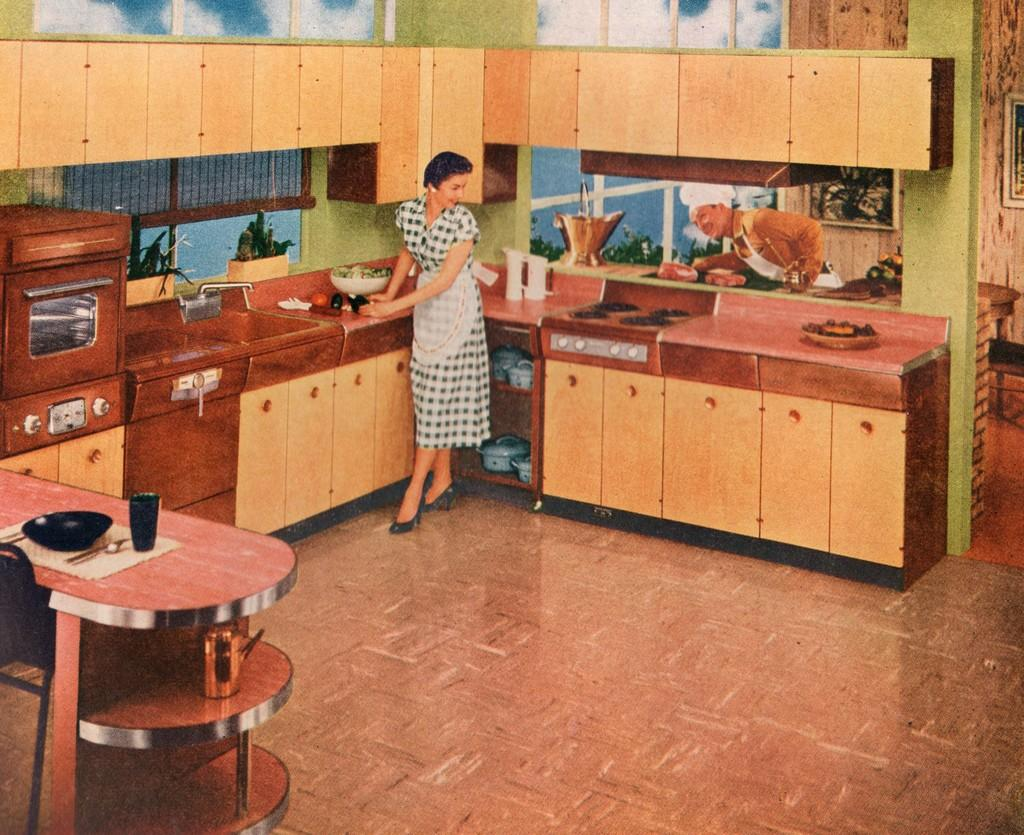What type of surface is visible in the image? There is a wooden platform in the image. What can be found on the wooden platform? There are objects on the wooden platform. What type of furniture is present in the image? There are cupboards in the image. Can you describe the people in the image? There is a person standing on the floor, and there is another person behind the first person. What is the writer doing in the image? There is no writer present in the image. How many divisions are visible in the image? The image does not depict any divisions; it shows a wooden platform, objects, cupboards, and people. 